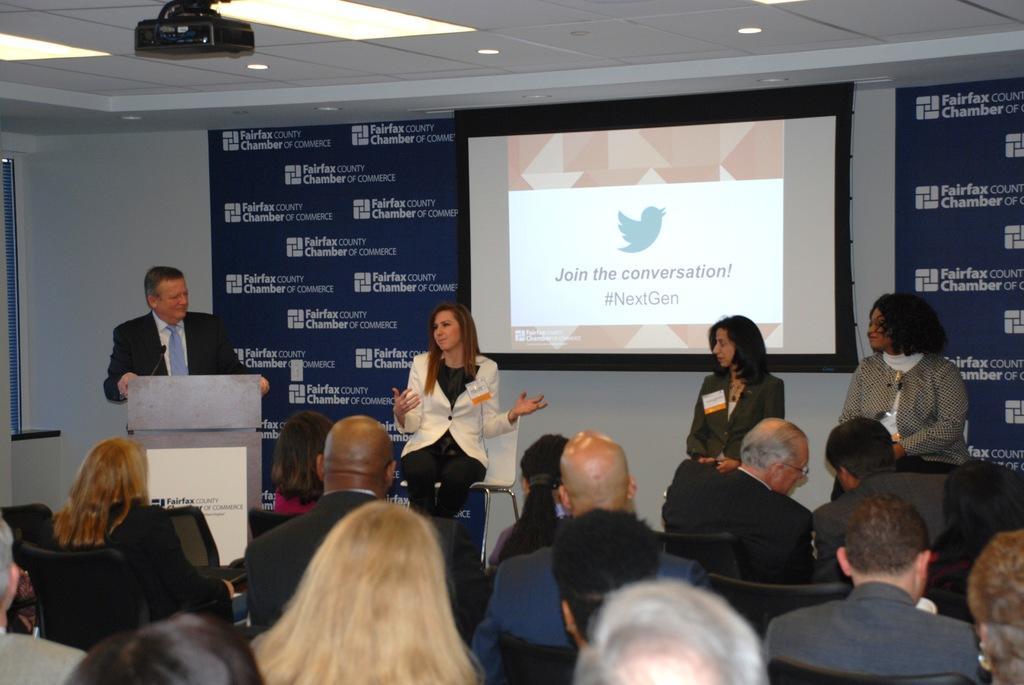Describe this image in one or two sentences. People are seated on the black chairs. 3 people are sitting on the stage. A person is standing at the left wearing a suit. There is a microphone and its table in front of him. There is a projector display and banners at the back. On the ceiling there are lights and a projector is present. 